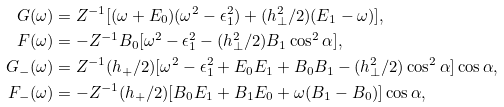Convert formula to latex. <formula><loc_0><loc_0><loc_500><loc_500>G ( \omega ) & = Z ^ { - 1 } [ ( \omega + E _ { 0 } ) ( \omega ^ { 2 } - \epsilon ^ { 2 } _ { 1 } ) + ( h ^ { 2 } _ { \perp } / 2 ) ( E _ { 1 } - \omega ) ] , \\ F ( \omega ) & = - Z ^ { - 1 } B _ { 0 } [ \omega ^ { 2 } - \epsilon ^ { 2 } _ { 1 } - ( h ^ { 2 } _ { \perp } / 2 ) B _ { 1 } \cos ^ { 2 } \alpha ] , \\ G _ { - } ( \omega ) & = Z ^ { - 1 } ( h _ { + } / 2 ) [ \omega ^ { 2 } - \epsilon ^ { 2 } _ { 1 } + E _ { 0 } E _ { 1 } + B _ { 0 } B _ { 1 } - ( h ^ { 2 } _ { \perp } / 2 ) \cos ^ { 2 } \alpha ] \cos \alpha , \\ F _ { - } ( \omega ) & = - Z ^ { - 1 } ( h _ { + } / 2 ) [ B _ { 0 } E _ { 1 } + B _ { 1 } E _ { 0 } + \omega ( B _ { 1 } - B _ { 0 } ) ] \cos \alpha ,</formula> 